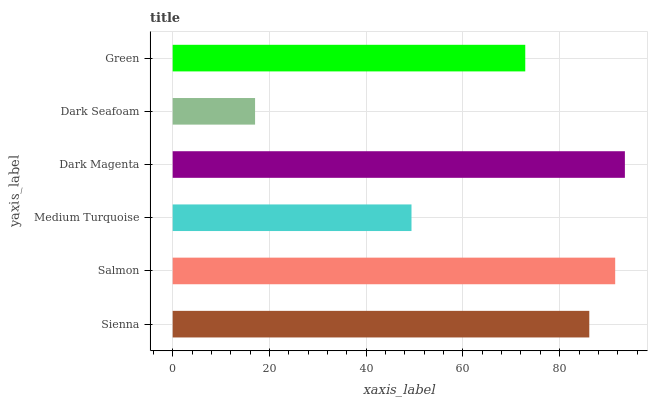Is Dark Seafoam the minimum?
Answer yes or no. Yes. Is Dark Magenta the maximum?
Answer yes or no. Yes. Is Salmon the minimum?
Answer yes or no. No. Is Salmon the maximum?
Answer yes or no. No. Is Salmon greater than Sienna?
Answer yes or no. Yes. Is Sienna less than Salmon?
Answer yes or no. Yes. Is Sienna greater than Salmon?
Answer yes or no. No. Is Salmon less than Sienna?
Answer yes or no. No. Is Sienna the high median?
Answer yes or no. Yes. Is Green the low median?
Answer yes or no. Yes. Is Green the high median?
Answer yes or no. No. Is Salmon the low median?
Answer yes or no. No. 